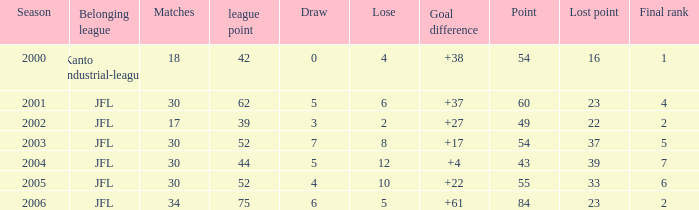What is the mean loss for lost points exceeding 16, goal difference below 37, and points under 43? None. 